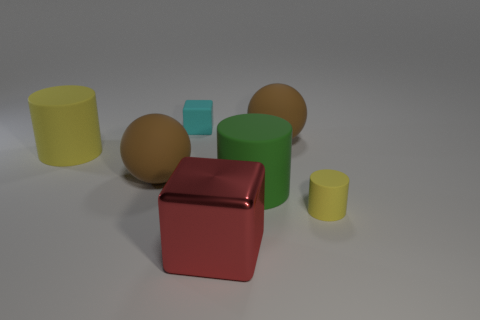Is the number of red shiny objects behind the large yellow cylinder the same as the number of matte things?
Offer a terse response. No. Does the yellow cylinder that is to the left of the red metal object have the same material as the tiny thing on the right side of the big green cylinder?
Your answer should be very brief. Yes. What number of things are either tiny cyan matte objects or objects behind the large metal object?
Your response must be concise. 6. Are there any metallic objects that have the same shape as the cyan matte object?
Provide a short and direct response. Yes. What is the size of the ball on the left side of the small thing that is on the left side of the yellow thing on the right side of the small cyan rubber block?
Give a very brief answer. Large. Are there the same number of small cubes in front of the big green cylinder and large green rubber cylinders in front of the small yellow object?
Keep it short and to the point. Yes. There is a green cylinder that is the same material as the cyan block; what size is it?
Your answer should be compact. Large. What color is the metallic thing?
Your answer should be compact. Red. What number of big rubber things are the same color as the tiny cylinder?
Your answer should be very brief. 1. What material is the cylinder that is the same size as the matte block?
Provide a succinct answer. Rubber. 